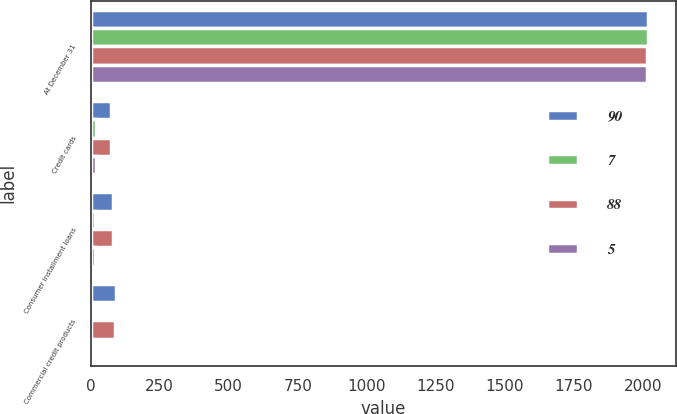Convert chart. <chart><loc_0><loc_0><loc_500><loc_500><stacked_bar_chart><ecel><fcel>At December 31<fcel>Credit cards<fcel>Consumer installment loans<fcel>Commercial credit products<nl><fcel>90<fcel>2018<fcel>74<fcel>80<fcel>90<nl><fcel>7<fcel>2018<fcel>18<fcel>14<fcel>5<nl><fcel>88<fcel>2017<fcel>73<fcel>79<fcel>88<nl><fcel>5<fcel>2017<fcel>19<fcel>15<fcel>7<nl></chart> 